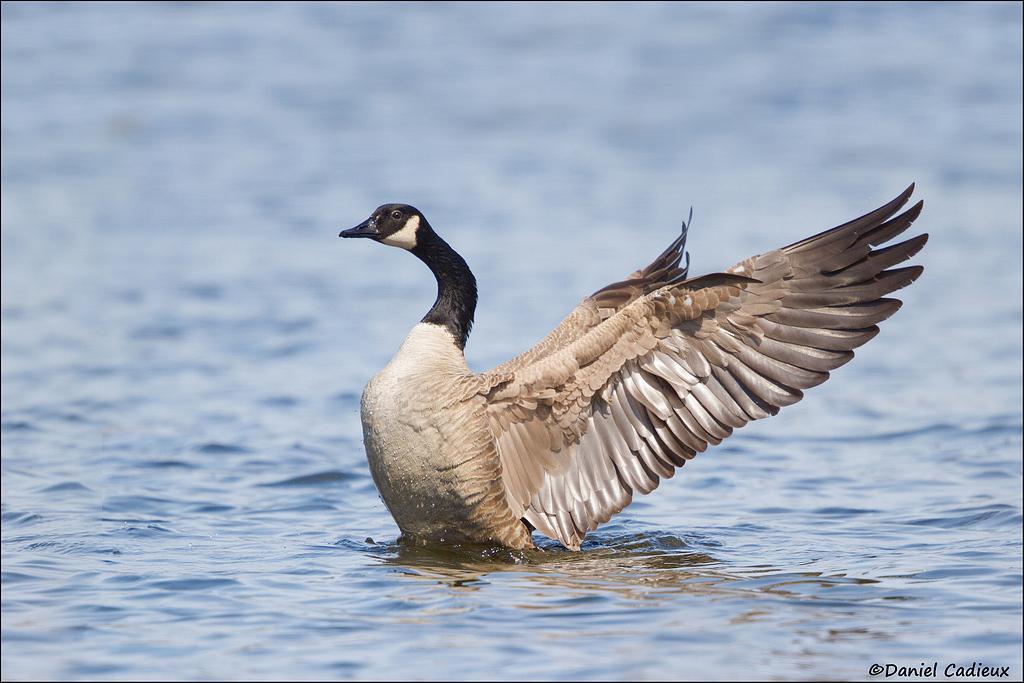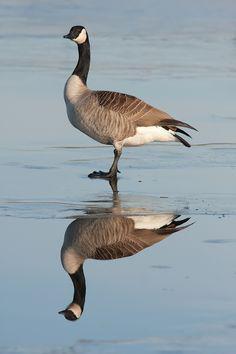The first image is the image on the left, the second image is the image on the right. For the images displayed, is the sentence "the bird on the left faces right and the bird on the right faces left" factually correct? Answer yes or no. No. 